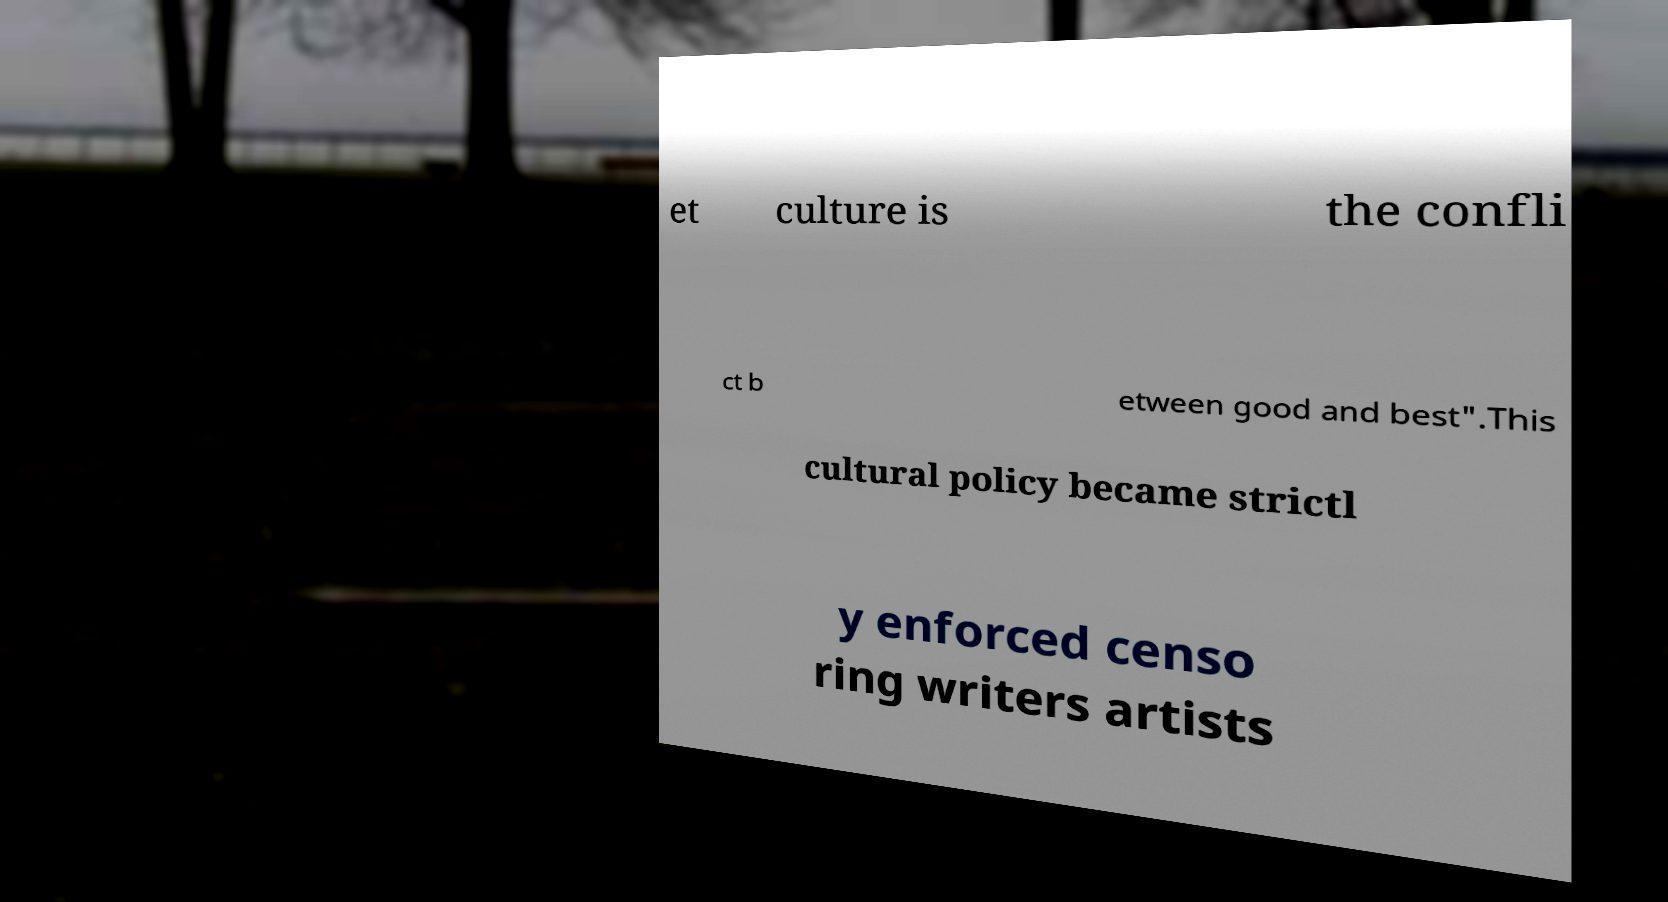Can you read and provide the text displayed in the image?This photo seems to have some interesting text. Can you extract and type it out for me? et culture is the confli ct b etween good and best".This cultural policy became strictl y enforced censo ring writers artists 